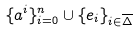Convert formula to latex. <formula><loc_0><loc_0><loc_500><loc_500>\{ a ^ { i } \} _ { i = 0 } ^ { n } \cup \{ e _ { i } \} _ { i \in \overline { \Delta } }</formula> 